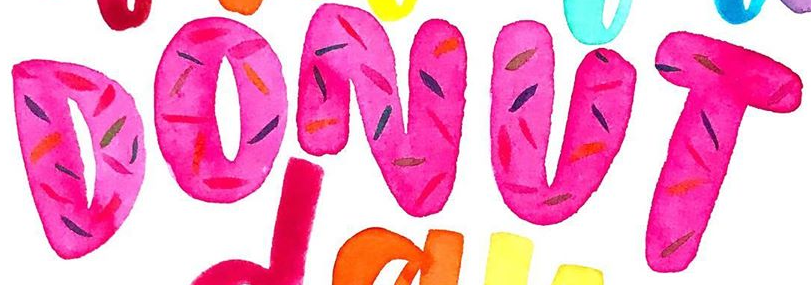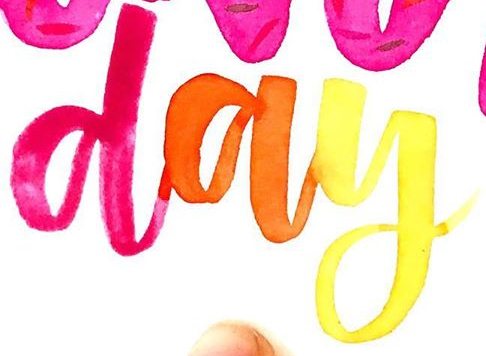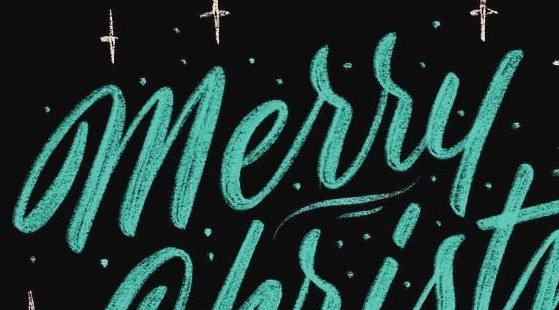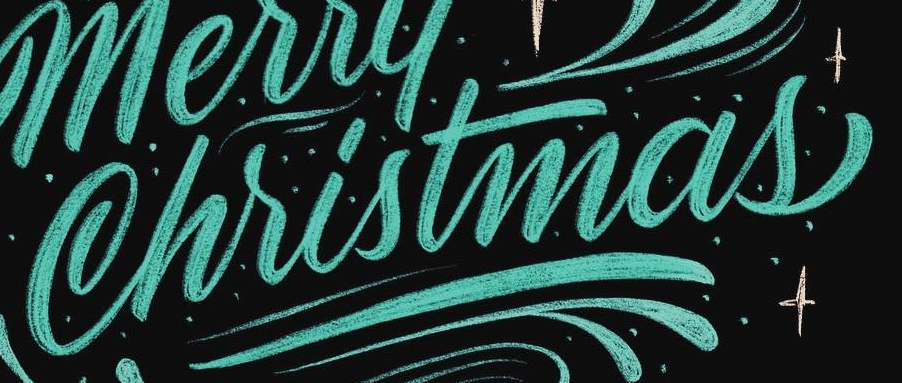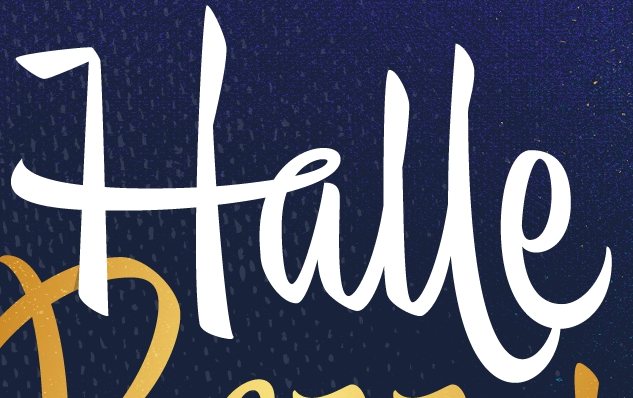Read the text from these images in sequence, separated by a semicolon. DONUT; day; Merry; Christmas; Halle 